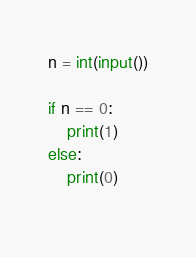Convert code to text. <code><loc_0><loc_0><loc_500><loc_500><_Python_>n = int(input())

if n == 0:
    print(1)
else:
    print(0)
    </code> 